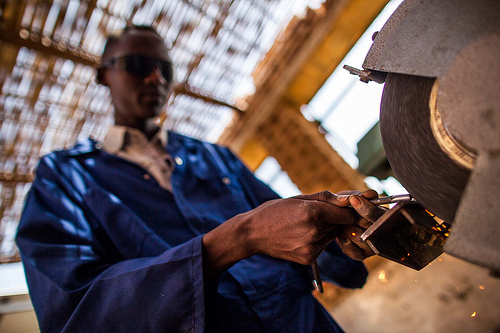<image>
Can you confirm if the man is on the roof? No. The man is not positioned on the roof. They may be near each other, but the man is not supported by or resting on top of the roof. 